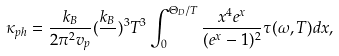Convert formula to latex. <formula><loc_0><loc_0><loc_500><loc_500>\kappa _ { p h } = \frac { k _ { B } } { 2 \pi ^ { 2 } v _ { p } } ( \frac { k _ { B } } { } ) ^ { 3 } T ^ { 3 } \int _ { 0 } ^ { \Theta _ { D } / T } \frac { x ^ { 4 } e ^ { x } } { ( e ^ { x } - 1 ) ^ { 2 } } \tau ( \omega , T ) d x ,</formula> 